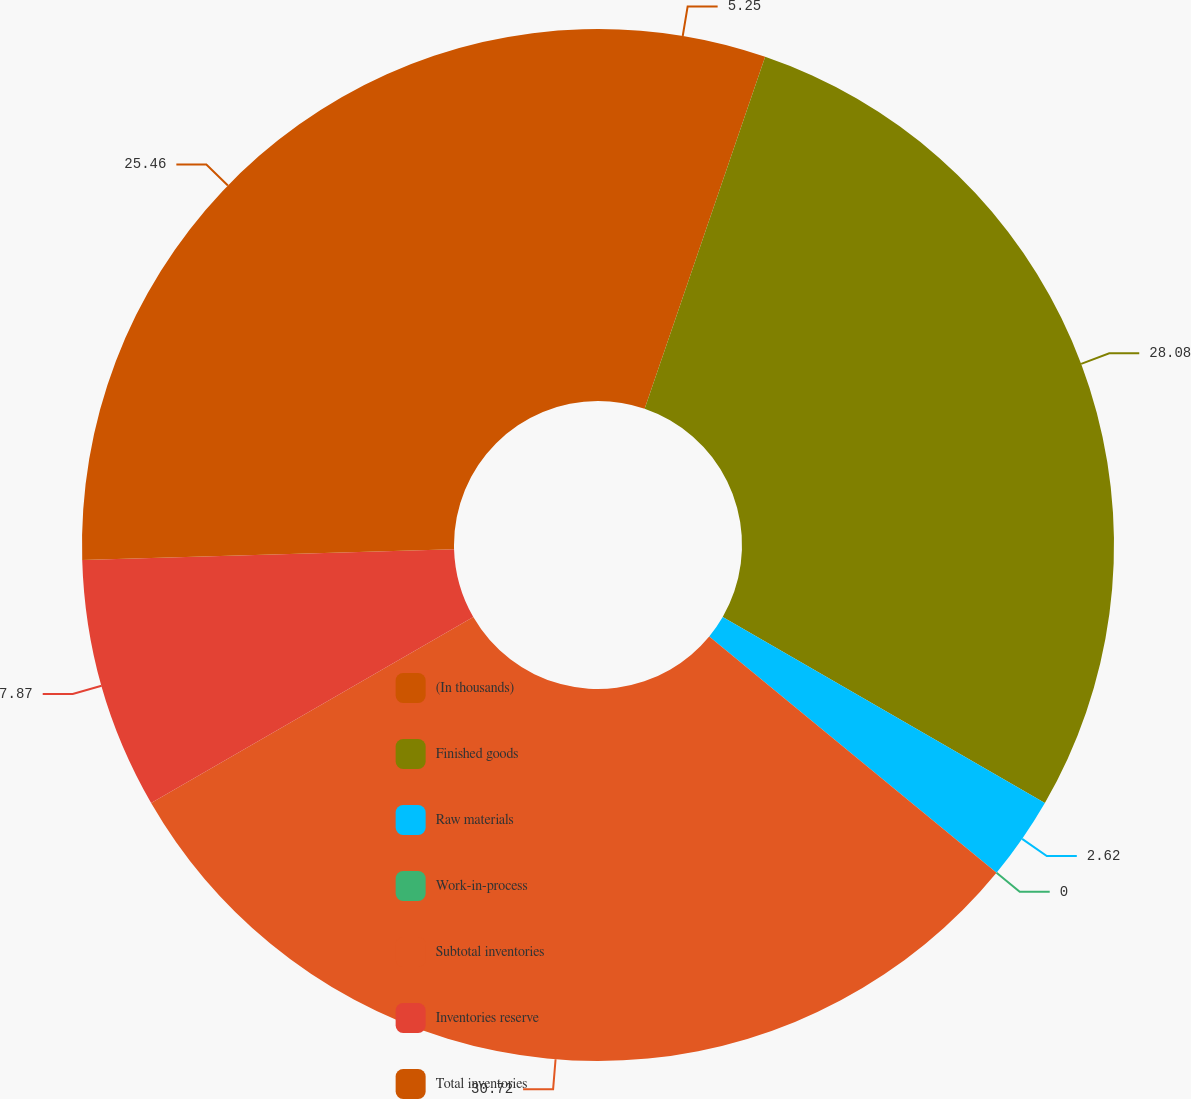Convert chart. <chart><loc_0><loc_0><loc_500><loc_500><pie_chart><fcel>(In thousands)<fcel>Finished goods<fcel>Raw materials<fcel>Work-in-process<fcel>Subtotal inventories<fcel>Inventories reserve<fcel>Total inventories<nl><fcel>5.25%<fcel>28.08%<fcel>2.62%<fcel>0.0%<fcel>30.71%<fcel>7.87%<fcel>25.46%<nl></chart> 